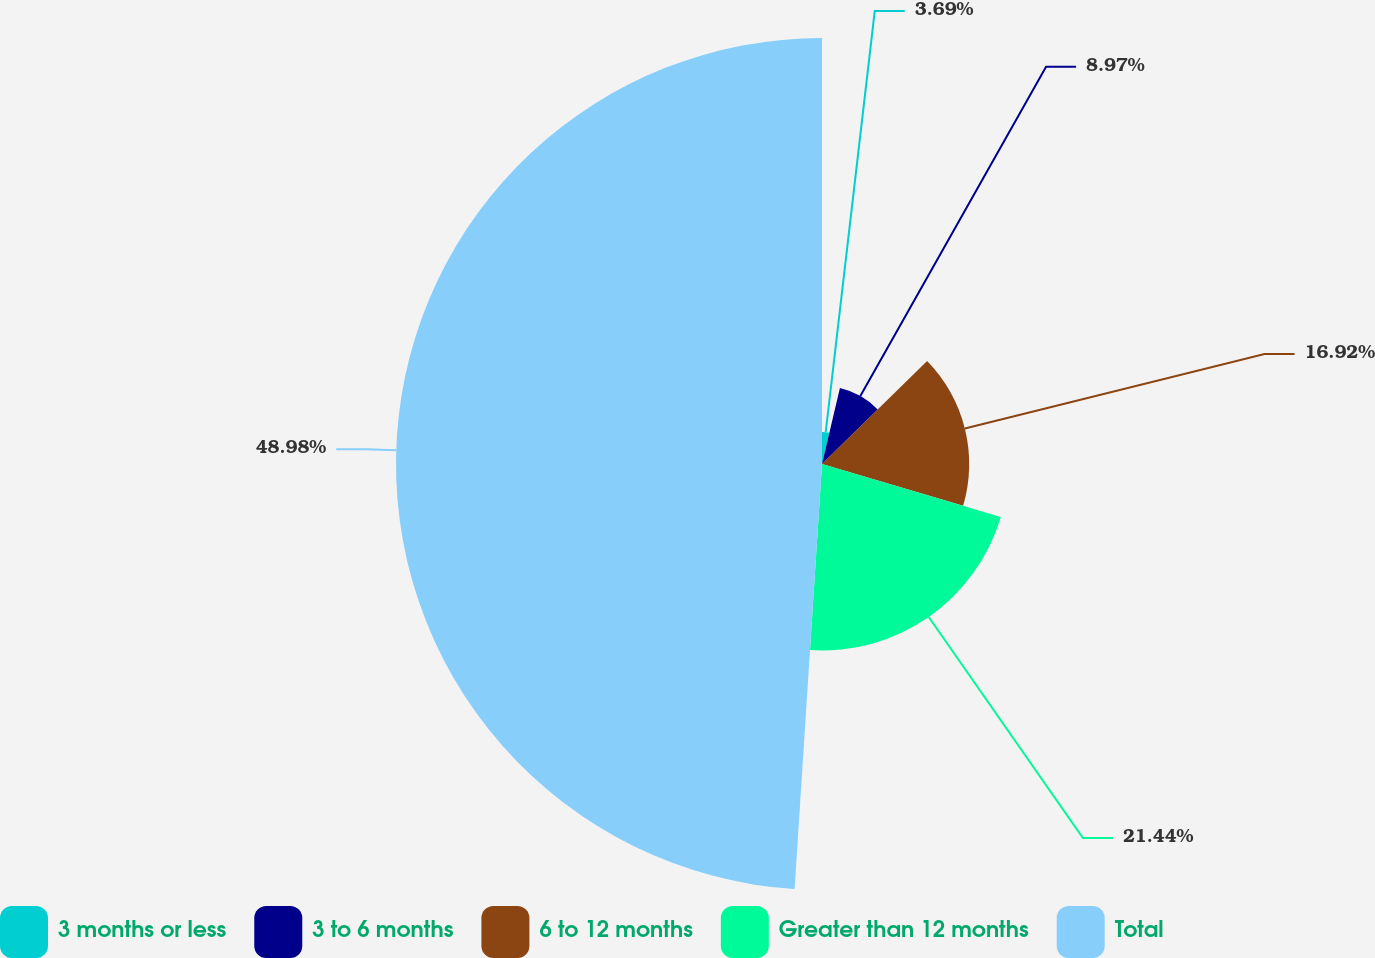<chart> <loc_0><loc_0><loc_500><loc_500><pie_chart><fcel>3 months or less<fcel>3 to 6 months<fcel>6 to 12 months<fcel>Greater than 12 months<fcel>Total<nl><fcel>3.69%<fcel>8.97%<fcel>16.92%<fcel>21.44%<fcel>48.97%<nl></chart> 